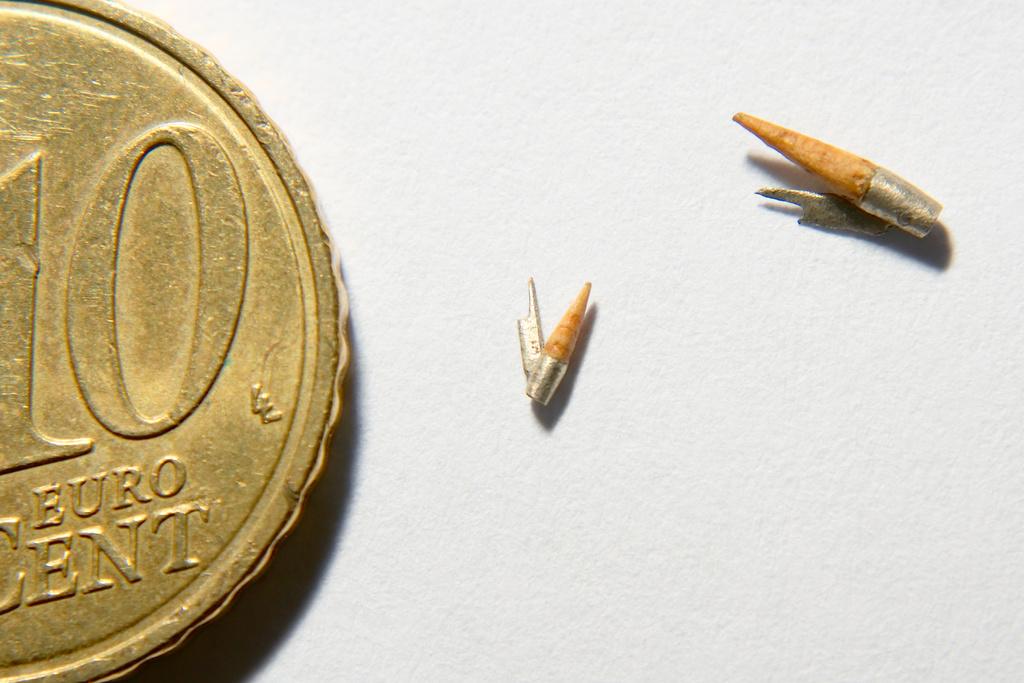What is the type of coin?
Give a very brief answer. Euro. 